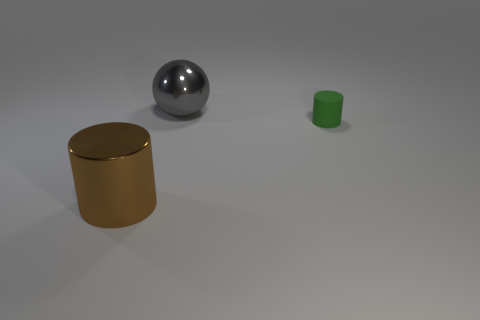What materials are the objects in the image made of? The three objects in the image appear to be made of different materials. The cylindrical object seems to be made of rubber with a matte finish, characterized by its lack of shine and green color. The sphere in the center has a reflective surface, indicative of a metallic material, possibly steel or aluminum. Lastly, the golden cylinder on the left, with its shiny appearance, could represent a polished metal or a plastic object with a metallic finish. 